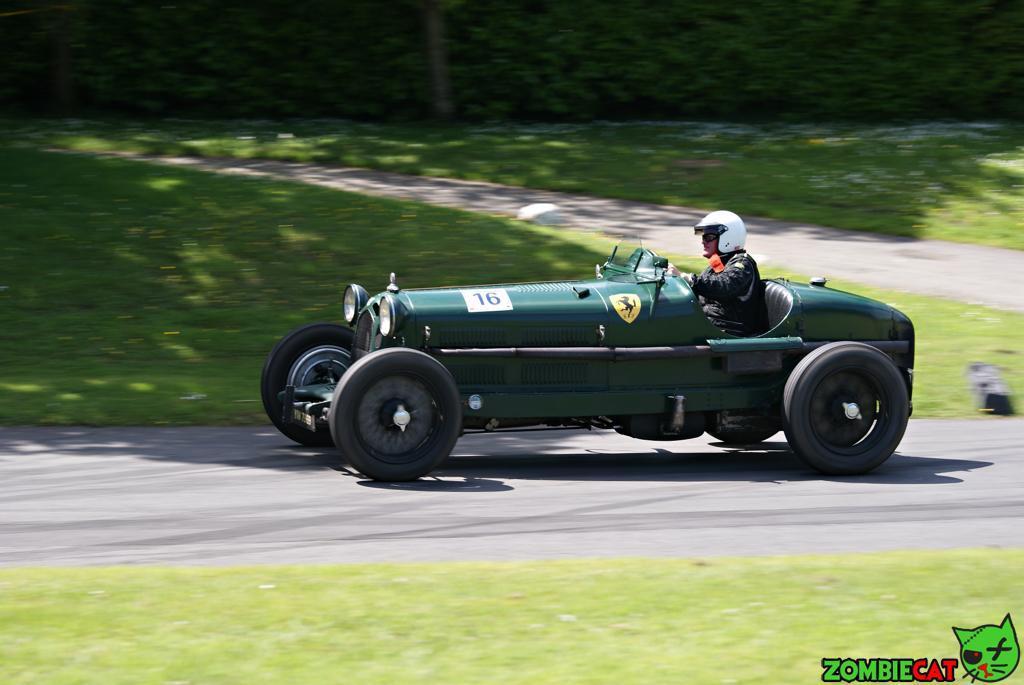In one or two sentences, can you explain what this image depicts? In this image we can see a car, one person wearing a helmet, we can see the grass, some written text at the bottom. 